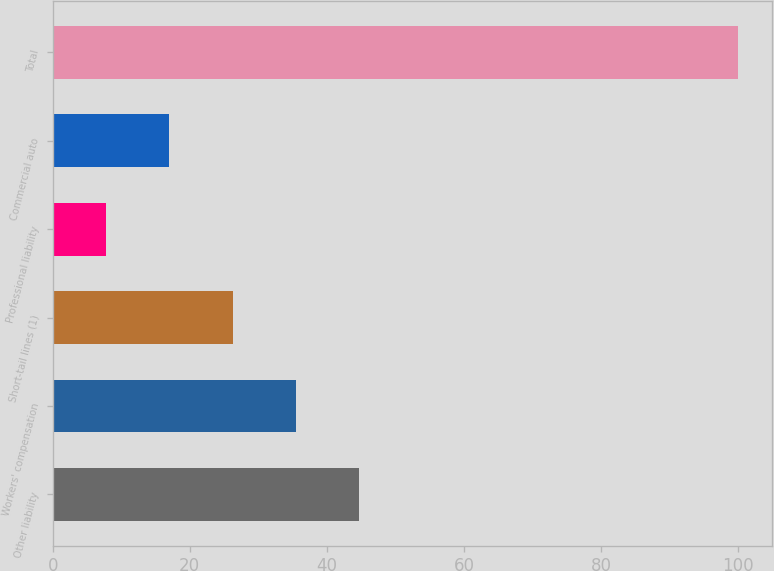Convert chart to OTSL. <chart><loc_0><loc_0><loc_500><loc_500><bar_chart><fcel>Other liability<fcel>Workers' compensation<fcel>Short-tail lines (1)<fcel>Professional liability<fcel>Commercial auto<fcel>Total<nl><fcel>44.68<fcel>35.46<fcel>26.24<fcel>7.8<fcel>17.02<fcel>100<nl></chart> 